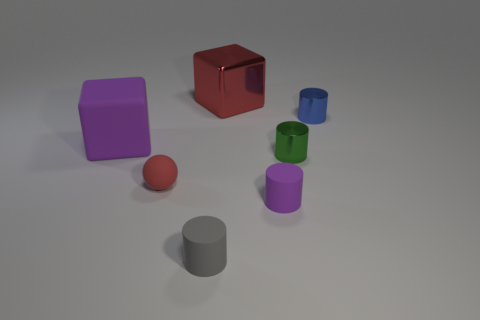Subtract 1 cylinders. How many cylinders are left? 3 Subtract all brown cylinders. Subtract all gray spheres. How many cylinders are left? 4 Add 1 large green shiny cylinders. How many objects exist? 8 Subtract all cylinders. How many objects are left? 3 Add 6 big cyan rubber objects. How many big cyan rubber objects exist? 6 Subtract 1 red blocks. How many objects are left? 6 Subtract all blue shiny objects. Subtract all metal cylinders. How many objects are left? 4 Add 6 red balls. How many red balls are left? 7 